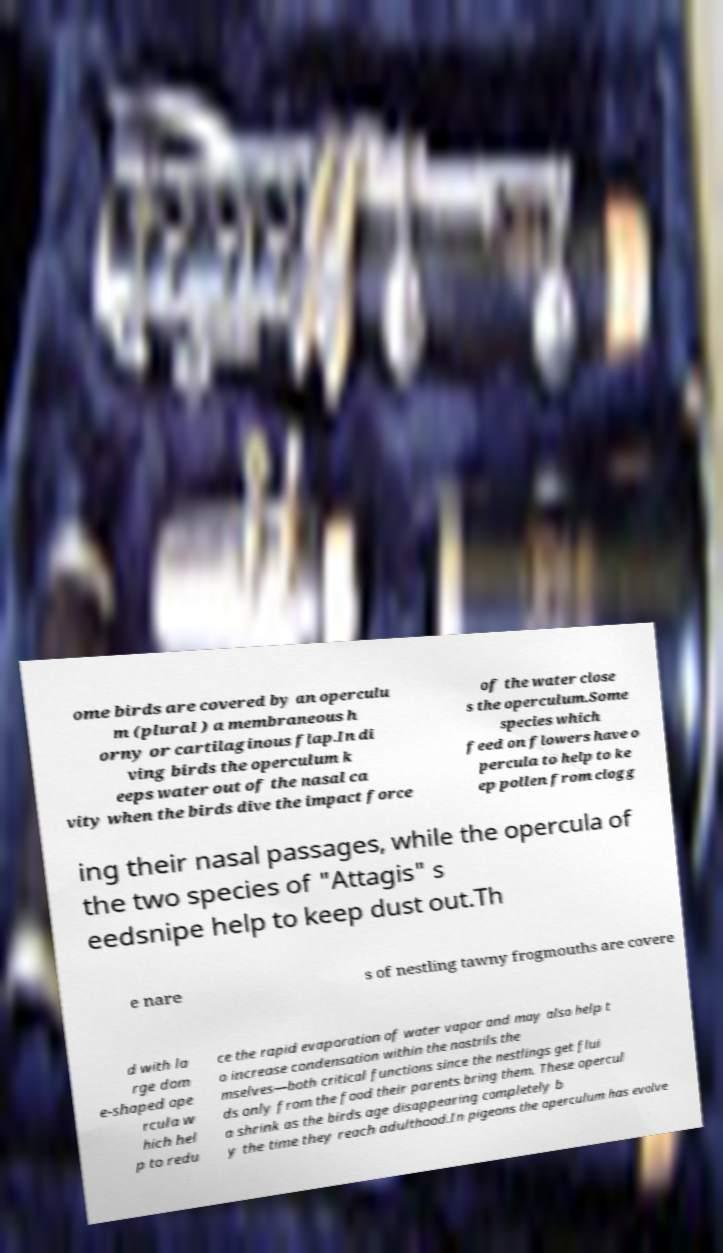There's text embedded in this image that I need extracted. Can you transcribe it verbatim? ome birds are covered by an operculu m (plural ) a membraneous h orny or cartilaginous flap.In di ving birds the operculum k eeps water out of the nasal ca vity when the birds dive the impact force of the water close s the operculum.Some species which feed on flowers have o percula to help to ke ep pollen from clogg ing their nasal passages, while the opercula of the two species of "Attagis" s eedsnipe help to keep dust out.Th e nare s of nestling tawny frogmouths are covere d with la rge dom e-shaped ope rcula w hich hel p to redu ce the rapid evaporation of water vapor and may also help t o increase condensation within the nostrils the mselves—both critical functions since the nestlings get flui ds only from the food their parents bring them. These opercul a shrink as the birds age disappearing completely b y the time they reach adulthood.In pigeons the operculum has evolve 